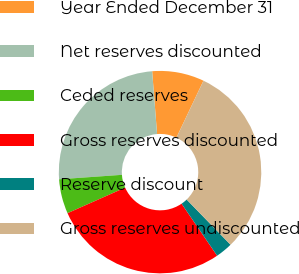Convert chart to OTSL. <chart><loc_0><loc_0><loc_500><loc_500><pie_chart><fcel>Year Ended December 31<fcel>Net reserves discounted<fcel>Ceded reserves<fcel>Gross reserves discounted<fcel>Reserve discount<fcel>Gross reserves undiscounted<nl><fcel>8.3%<fcel>24.89%<fcel>5.52%<fcel>27.89%<fcel>2.73%<fcel>30.68%<nl></chart> 